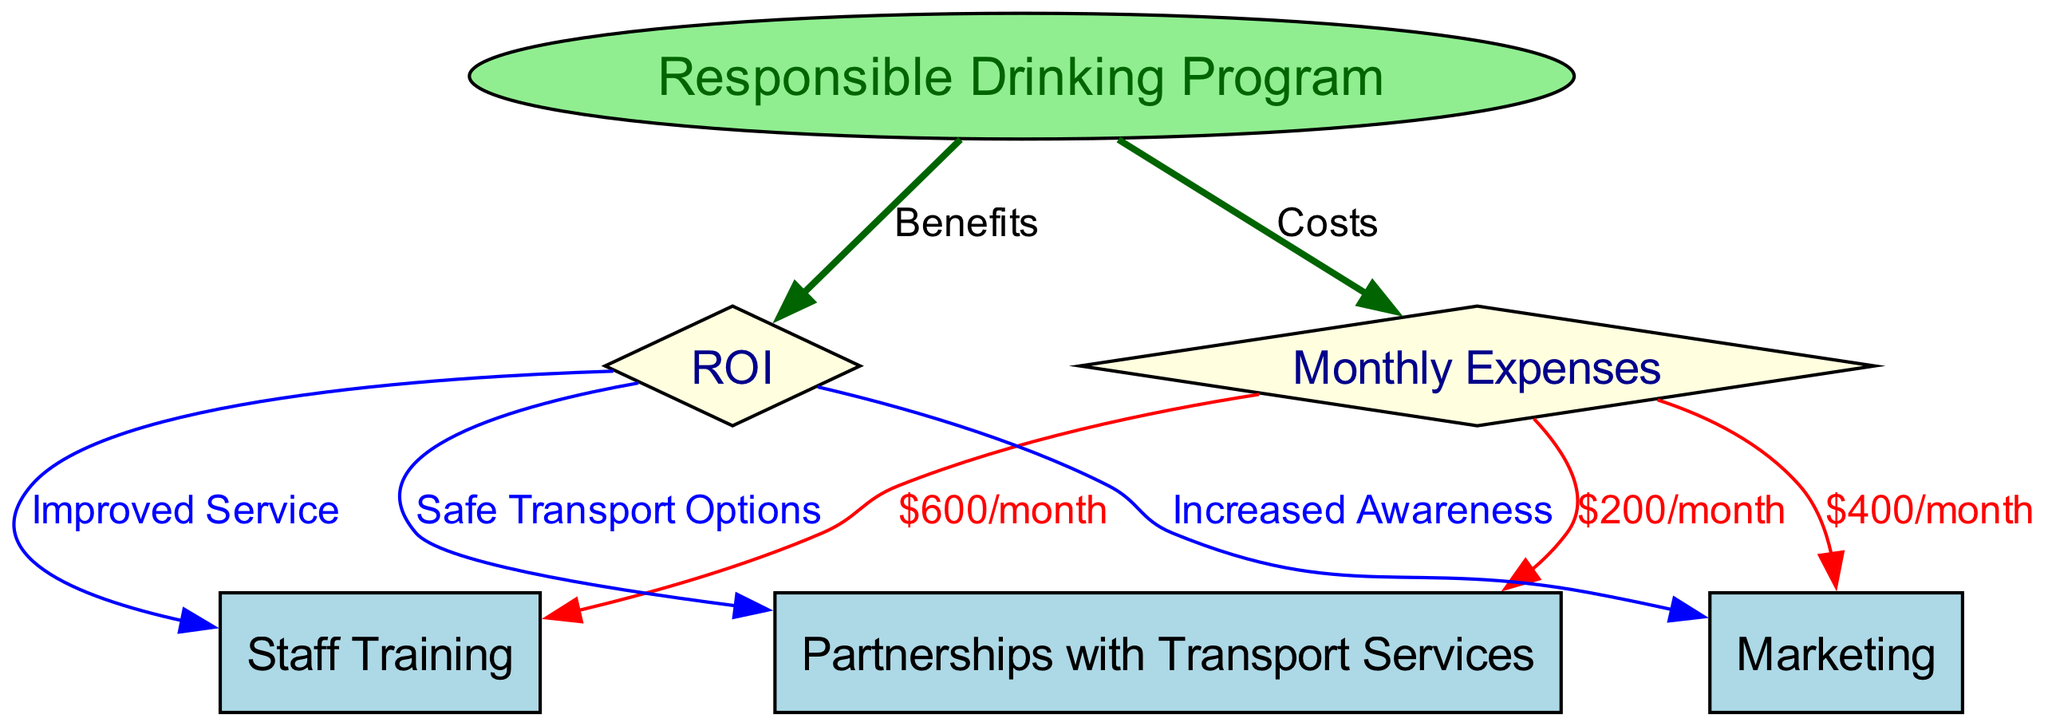What are the total monthly expenses for the responsible drinking program? The total monthly expenses are represented by three specific contributions: $600 for staff training, $400 for marketing, and $200 for partnerships with transport services. Adding these amounts gives us a total of $600 + $400 + $200 = $1200.
Answer: $1200 What type of program is being implemented? The program being implemented is labeled as the "Responsible Drinking Program," which is indicated in the diagram and central to the expenses and ROI depicted.
Answer: Responsible Drinking Program How much is allocated to staff training each month? The diagram directly lists the allocation for staff training as $600 per month, illustrated by the edge connecting "monthly expenses" to "staff training."
Answer: $600/month What is the purpose of the partnerships with transport services? The partnerships with transport services aim to provide "Safe Transport Options," which is highlighted in the diagram as a benefit arising from the ROI.
Answer: Safe Transport Options What are the benefits associated with improved service? Improved service is a result of the investments in staff training, which is reflected in the ROI node connected to the staff training node. This signifies that better-trained staff enhance overall service quality.
Answer: Improved Service What is indicated by the diamond shape nodes in the diagram? The diamond shape nodes in the diagram indicate key concepts, namely "Monthly Expenses" and "ROI." These represent important financial metrics related to the implementation of the program.
Answer: Monthly Expenses and ROI How many edges are connected to the ROI node? The ROI node is connected to three edges, as it illustrates the benefits derived from the program implementation: improved service from staff training, increased awareness from marketing, and safe transport options from partnerships.
Answer: 3 What is the connection between monthly expenses and marketing? The connection is indicated by an edge that specifies the cost associated with marketing as $400 per month, which reflects the financial commitment made towards advertising the responsible drinking program.
Answer: $400/month What color indicates costs in the diagram? The edges that indicate costs in the diagram are colored dark green, which represents the direction from "program implementation" to "monthly expenses."
Answer: Dark green 